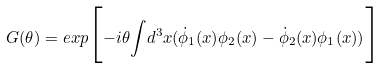Convert formula to latex. <formula><loc_0><loc_0><loc_500><loc_500>G ( \theta ) = e x p { \Big { [ } } { - i \theta { \int } d ^ { 3 } x ( \dot { \phi } _ { 1 } ( x ) \phi _ { 2 } ( x ) - \dot { \phi } _ { 2 } ( x ) \phi _ { 1 } ( x ) ) } { \Big { ] } }</formula> 